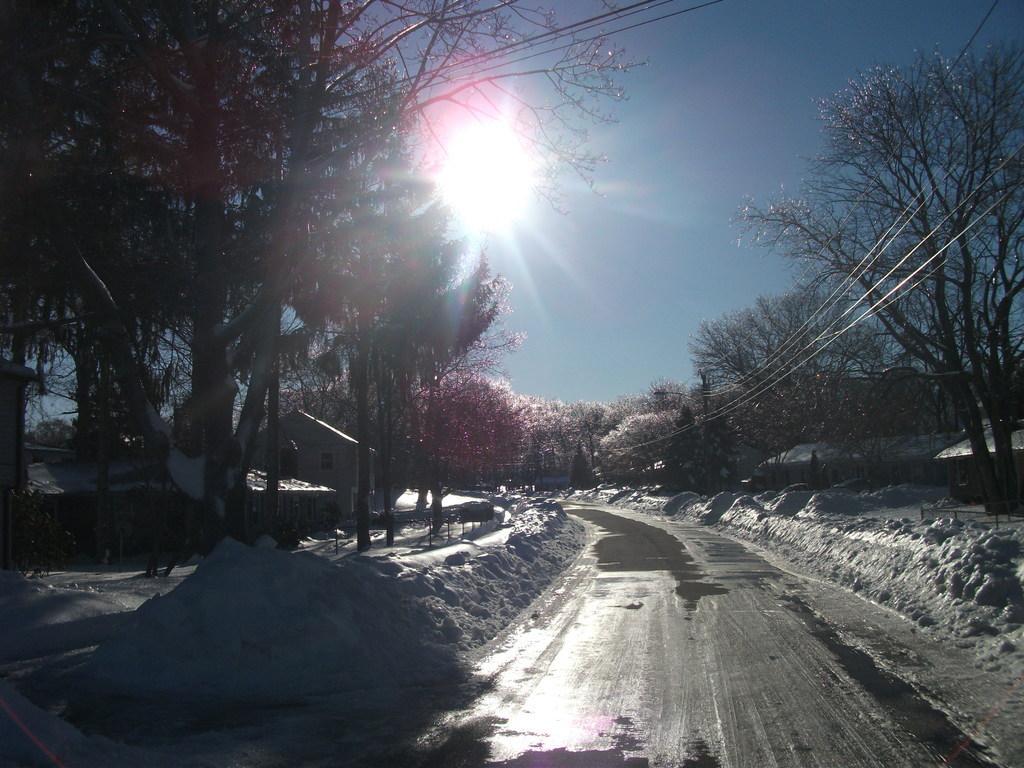Can you describe this image briefly? In this picture there is way at the bottom side of the image and there are flower trees and snow on the right and left side of the image, there is sun in the sky. 